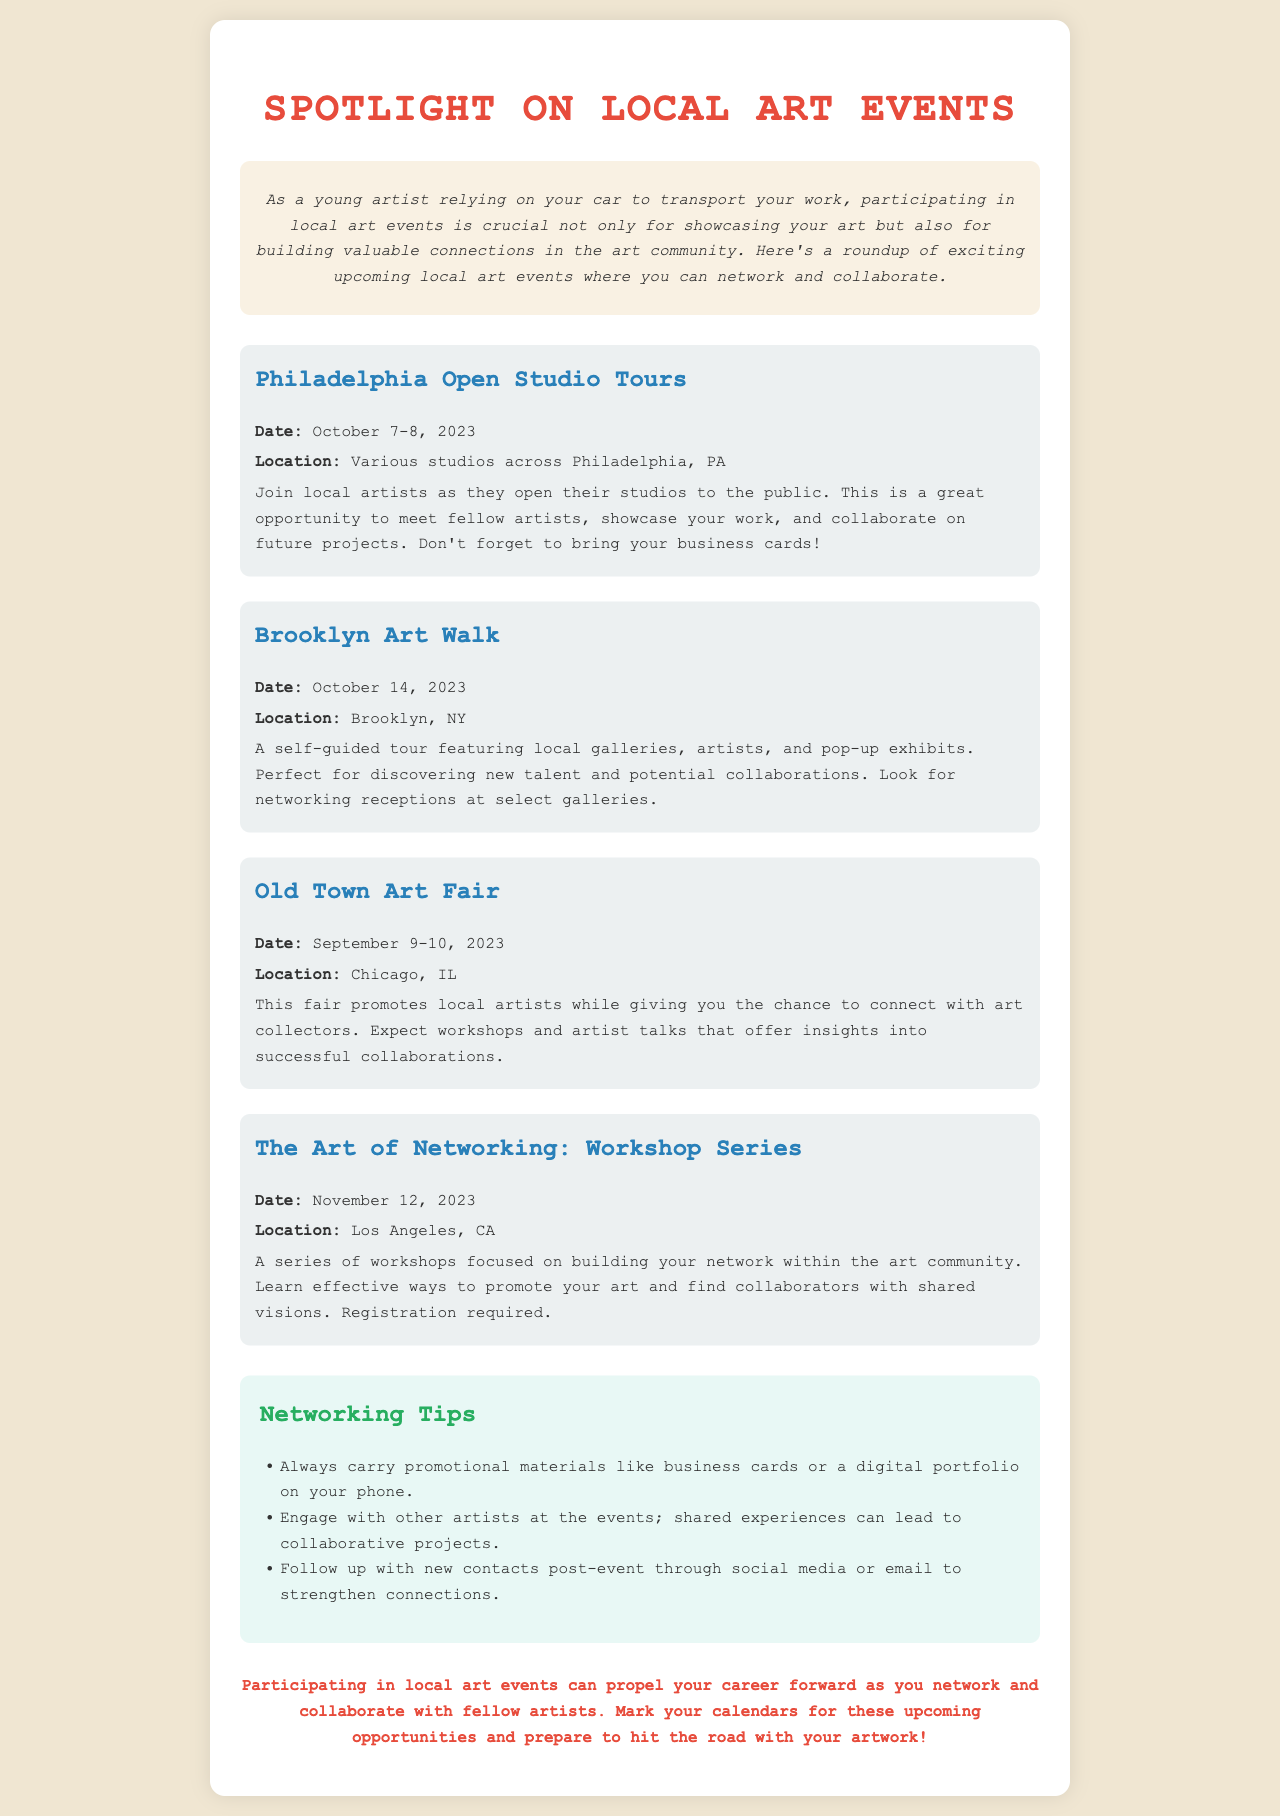What is the title of the newsletter? The title is prominently displayed at the top of the document, indicating the focus of the newsletter.
Answer: Spotlight on Local Art Events When is the Philadelphia Open Studio Tours event? The date is clearly mentioned under the event description, allowing readers to note the timing.
Answer: October 7-8, 2023 Where is The Art of Networking workshop series held? The location of the event is specified for participants to plan accordingly.
Answer: Los Angeles, CA What is a recommended item to bring to the Philadelphia Open Studio Tours? The document suggests bringing this item to aid in networking during the event.
Answer: Business cards What is the purpose of the Brooklyn Art Walk event? This event description outlines its goal for participants regarding networking and discovery.
Answer: Discovering new talent and potential collaborations Which event occurs before the Old Town Art Fair? The phrasing requires looking at the dates of the events listed in chronological order.
Answer: Philadelphia Open Studio Tours How many tips are provided for networking? The number of tips is stated under the networking tips section, guiding artists on effective networking strategies.
Answer: Three What is the primary focus of "The Art of Networking: Workshop Series"? The document details the primary focus of these workshops related to community building and promotion.
Answer: Building your network What color is the background of the newsletter? The background color is indicated in the style section, setting the visual theme for the document.
Answer: #f0e6d2 